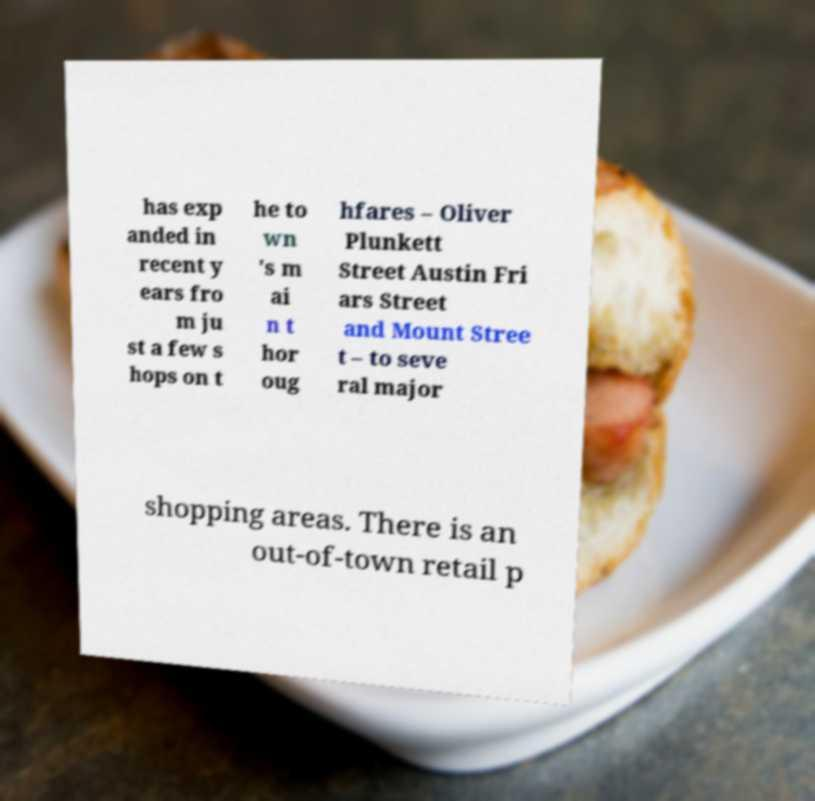Could you extract and type out the text from this image? has exp anded in recent y ears fro m ju st a few s hops on t he to wn 's m ai n t hor oug hfares – Oliver Plunkett Street Austin Fri ars Street and Mount Stree t – to seve ral major shopping areas. There is an out-of-town retail p 